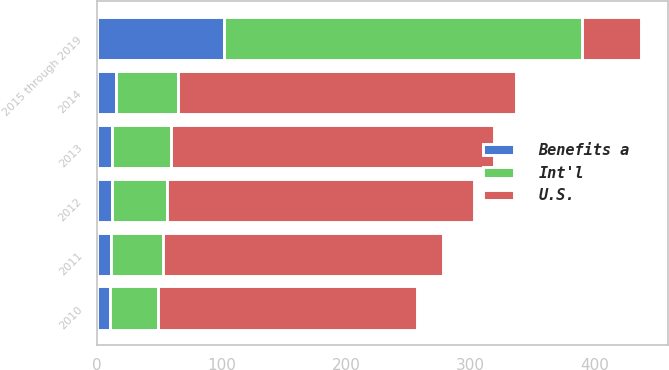Convert chart to OTSL. <chart><loc_0><loc_0><loc_500><loc_500><stacked_bar_chart><ecel><fcel>2010<fcel>2011<fcel>2012<fcel>2013<fcel>2014<fcel>2015 through 2019<nl><fcel>U.S.<fcel>208<fcel>225<fcel>247<fcel>260<fcel>272<fcel>47<nl><fcel>Benefits a<fcel>10<fcel>11<fcel>12<fcel>12<fcel>15<fcel>102<nl><fcel>Int'l<fcel>39<fcel>42<fcel>44<fcel>47<fcel>50<fcel>288<nl></chart> 